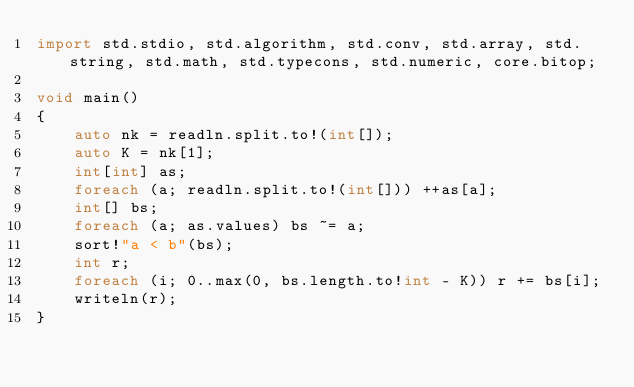<code> <loc_0><loc_0><loc_500><loc_500><_D_>import std.stdio, std.algorithm, std.conv, std.array, std.string, std.math, std.typecons, std.numeric, core.bitop;

void main()
{
    auto nk = readln.split.to!(int[]);
    auto K = nk[1];
    int[int] as;
    foreach (a; readln.split.to!(int[])) ++as[a];
    int[] bs;
    foreach (a; as.values) bs ~= a;
    sort!"a < b"(bs);
    int r;
    foreach (i; 0..max(0, bs.length.to!int - K)) r += bs[i];
    writeln(r);
}</code> 